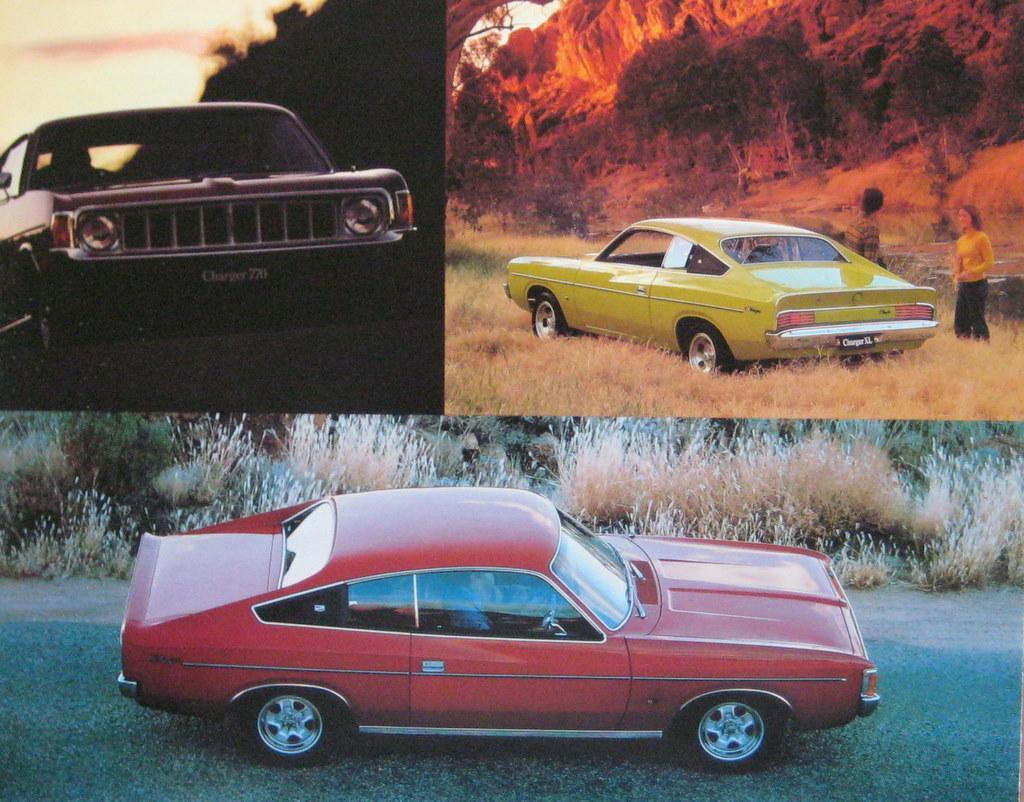Describe this image in one or two sentences. In this image I can see three cars. They are in red,yellow and black color. Back I can see a trees and two people. We can see dry grass. 